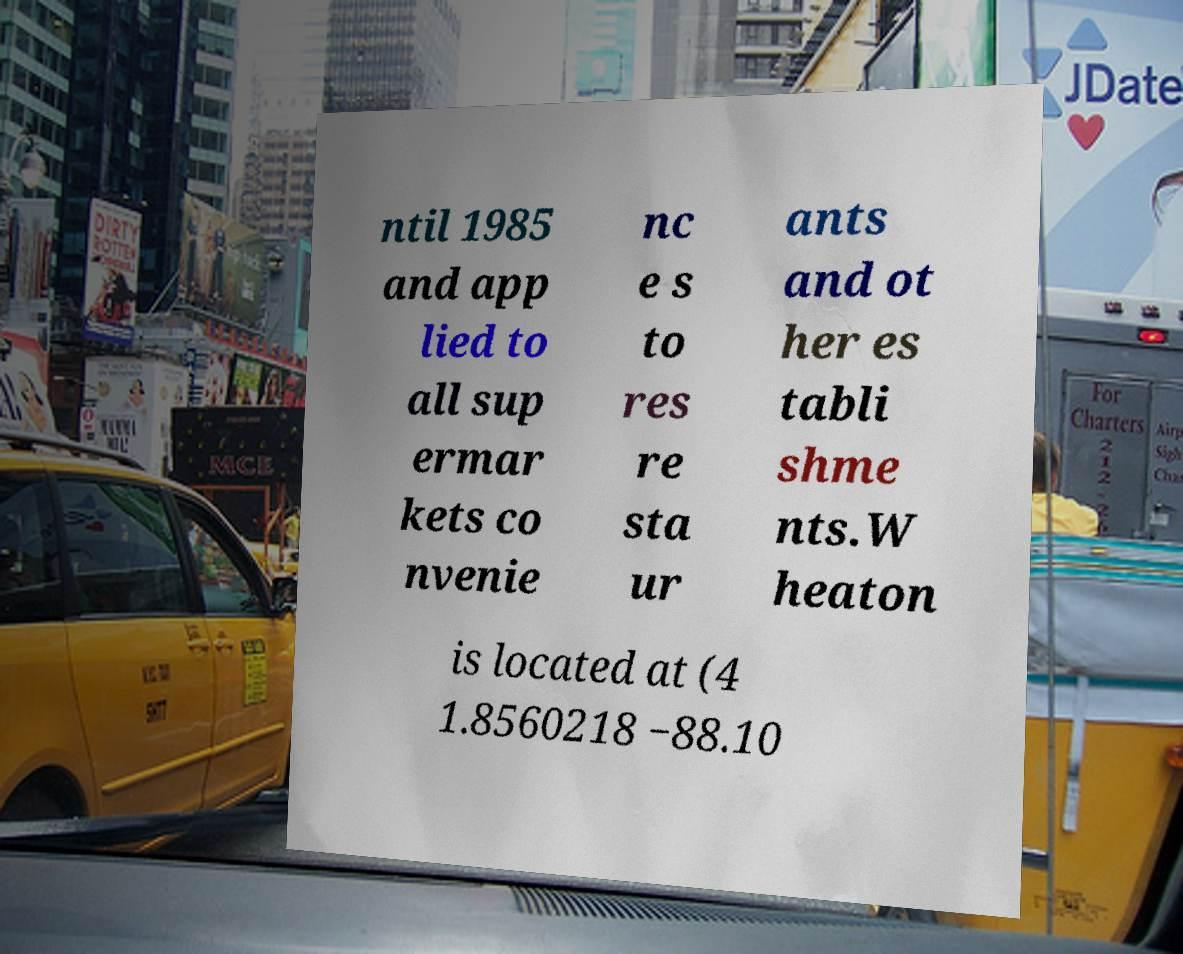Can you read and provide the text displayed in the image?This photo seems to have some interesting text. Can you extract and type it out for me? ntil 1985 and app lied to all sup ermar kets co nvenie nc e s to res re sta ur ants and ot her es tabli shme nts.W heaton is located at (4 1.8560218 −88.10 